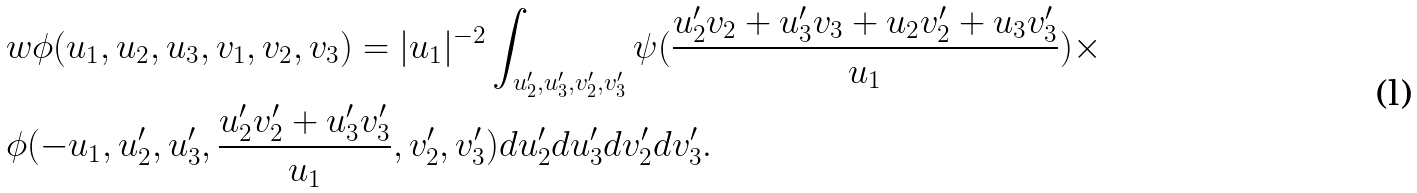Convert formula to latex. <formula><loc_0><loc_0><loc_500><loc_500>& w \phi ( u _ { 1 } , u _ { 2 } , u _ { 3 } , v _ { 1 } , v _ { 2 } , v _ { 3 } ) = | u _ { 1 } | ^ { - 2 } \int _ { u ^ { \prime } _ { 2 } , u ^ { \prime } _ { 3 } , v ^ { \prime } _ { 2 } , v ^ { \prime } _ { 3 } } \psi ( \frac { u ^ { \prime } _ { 2 } v _ { 2 } + u ^ { \prime } _ { 3 } v _ { 3 } + u _ { 2 } v ^ { \prime } _ { 2 } + u _ { 3 } v ^ { \prime } _ { 3 } } { u _ { 1 } } ) \times \\ & \phi ( - u _ { 1 } , u ^ { \prime } _ { 2 } , u ^ { \prime } _ { 3 } , \frac { u ^ { \prime } _ { 2 } v ^ { \prime } _ { 2 } + u ^ { \prime } _ { 3 } v ^ { \prime } _ { 3 } } { u _ { 1 } } , v ^ { \prime } _ { 2 } , v ^ { \prime } _ { 3 } ) d u ^ { \prime } _ { 2 } d u ^ { \prime } _ { 3 } d v ^ { \prime } _ { 2 } d v ^ { \prime } _ { 3 } .</formula> 